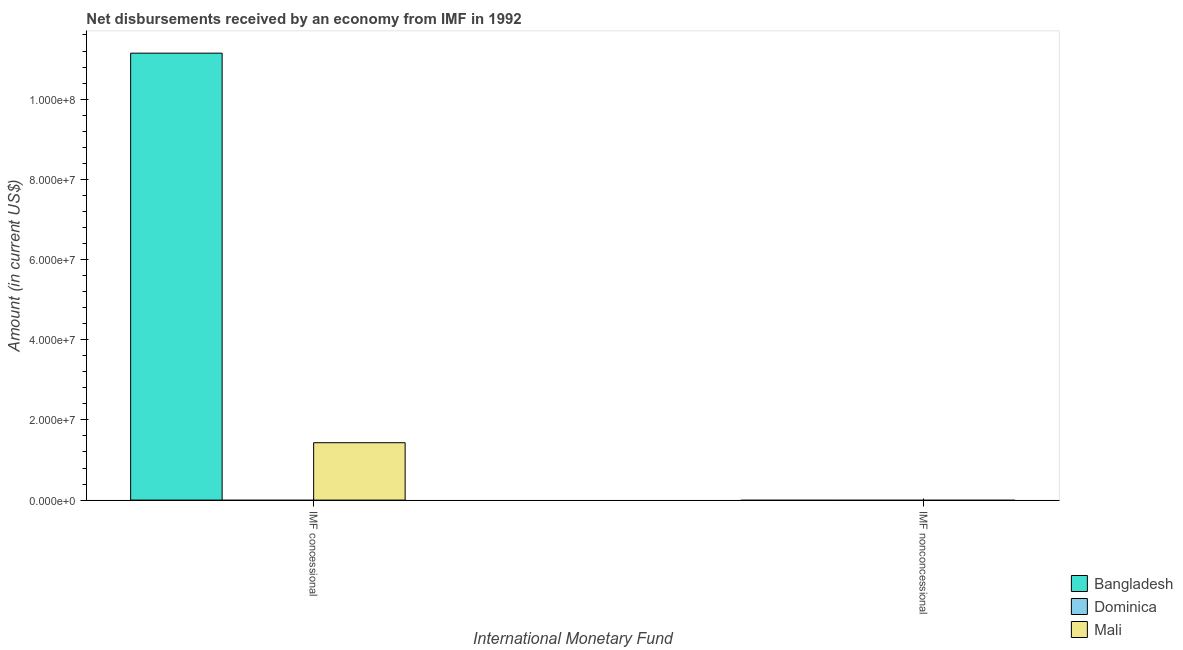Are the number of bars on each tick of the X-axis equal?
Provide a succinct answer. No. What is the label of the 1st group of bars from the left?
Ensure brevity in your answer.  IMF concessional. What is the net non concessional disbursements from imf in Dominica?
Give a very brief answer. 0. Across all countries, what is the maximum net concessional disbursements from imf?
Provide a succinct answer. 1.11e+08. What is the total net concessional disbursements from imf in the graph?
Make the answer very short. 1.26e+08. What is the difference between the net concessional disbursements from imf in Bangladesh and that in Mali?
Your answer should be very brief. 9.72e+07. What is the average net concessional disbursements from imf per country?
Offer a terse response. 4.19e+07. In how many countries, is the net concessional disbursements from imf greater than 24000000 US$?
Your response must be concise. 1. What is the ratio of the net concessional disbursements from imf in Mali to that in Bangladesh?
Make the answer very short. 0.13. Is the net concessional disbursements from imf in Bangladesh less than that in Mali?
Make the answer very short. No. How many bars are there?
Keep it short and to the point. 2. What is the difference between two consecutive major ticks on the Y-axis?
Offer a terse response. 2.00e+07. Where does the legend appear in the graph?
Your answer should be compact. Bottom right. How many legend labels are there?
Offer a very short reply. 3. How are the legend labels stacked?
Offer a terse response. Vertical. What is the title of the graph?
Your answer should be very brief. Net disbursements received by an economy from IMF in 1992. What is the label or title of the X-axis?
Offer a terse response. International Monetary Fund. What is the Amount (in current US$) in Bangladesh in IMF concessional?
Your answer should be compact. 1.11e+08. What is the Amount (in current US$) in Dominica in IMF concessional?
Your answer should be very brief. 0. What is the Amount (in current US$) in Mali in IMF concessional?
Ensure brevity in your answer.  1.43e+07. What is the Amount (in current US$) in Bangladesh in IMF nonconcessional?
Your answer should be very brief. 0. What is the Amount (in current US$) of Dominica in IMF nonconcessional?
Ensure brevity in your answer.  0. Across all International Monetary Fund, what is the maximum Amount (in current US$) in Bangladesh?
Keep it short and to the point. 1.11e+08. Across all International Monetary Fund, what is the maximum Amount (in current US$) in Mali?
Offer a very short reply. 1.43e+07. Across all International Monetary Fund, what is the minimum Amount (in current US$) of Mali?
Make the answer very short. 0. What is the total Amount (in current US$) in Bangladesh in the graph?
Your answer should be very brief. 1.11e+08. What is the total Amount (in current US$) of Dominica in the graph?
Make the answer very short. 0. What is the total Amount (in current US$) of Mali in the graph?
Offer a terse response. 1.43e+07. What is the average Amount (in current US$) in Bangladesh per International Monetary Fund?
Provide a short and direct response. 5.57e+07. What is the average Amount (in current US$) of Mali per International Monetary Fund?
Keep it short and to the point. 7.16e+06. What is the difference between the Amount (in current US$) in Bangladesh and Amount (in current US$) in Mali in IMF concessional?
Ensure brevity in your answer.  9.72e+07. What is the difference between the highest and the lowest Amount (in current US$) of Bangladesh?
Keep it short and to the point. 1.11e+08. What is the difference between the highest and the lowest Amount (in current US$) of Mali?
Your answer should be compact. 1.43e+07. 